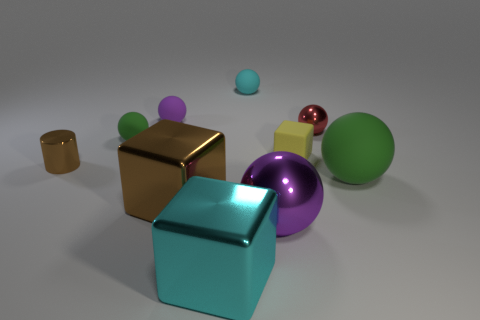Subtract 2 balls. How many balls are left? 4 Subtract all purple metallic balls. How many balls are left? 5 Subtract all purple balls. How many balls are left? 4 Subtract all gray spheres. Subtract all cyan blocks. How many spheres are left? 6 Subtract all cubes. How many objects are left? 7 Add 1 big brown metallic blocks. How many big brown metallic blocks exist? 2 Subtract 0 red blocks. How many objects are left? 10 Subtract all big balls. Subtract all cyan shiny cubes. How many objects are left? 7 Add 7 big cyan shiny cubes. How many big cyan shiny cubes are left? 8 